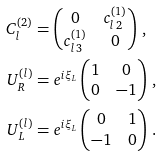<formula> <loc_0><loc_0><loc_500><loc_500>C ^ { ( 2 ) } _ { l } & = \begin{pmatrix} 0 & c ^ { ( 1 ) } _ { l \, 2 } \\ c ^ { ( 1 ) } _ { l \, 3 } & 0 \end{pmatrix} \, , \\ U _ { R } ^ { ( l ) } & = e ^ { i \xi _ { L } } \begin{pmatrix} 1 & 0 \\ 0 & - 1 \end{pmatrix} \, , \\ U _ { L } ^ { ( l ) } & = e ^ { i \xi _ { L } } \begin{pmatrix} 0 & 1 \\ - 1 & 0 \end{pmatrix} \, .</formula> 